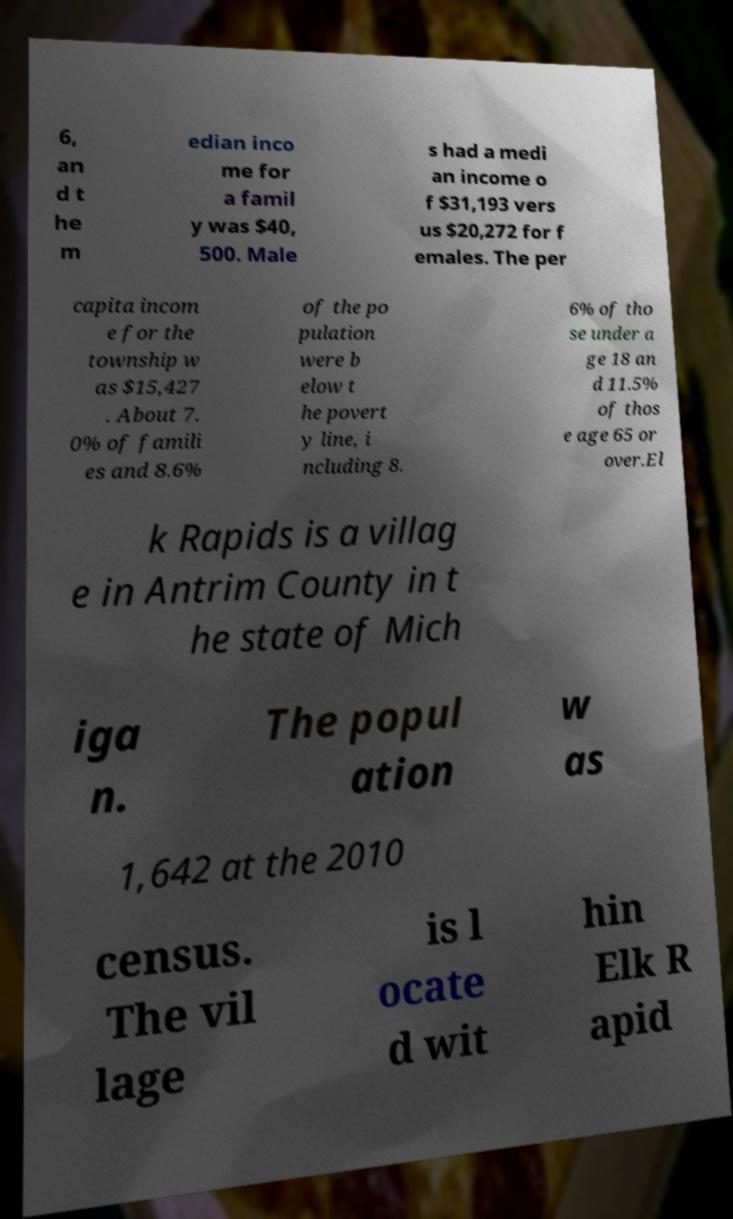Could you extract and type out the text from this image? 6, an d t he m edian inco me for a famil y was $40, 500. Male s had a medi an income o f $31,193 vers us $20,272 for f emales. The per capita incom e for the township w as $15,427 . About 7. 0% of famili es and 8.6% of the po pulation were b elow t he povert y line, i ncluding 8. 6% of tho se under a ge 18 an d 11.5% of thos e age 65 or over.El k Rapids is a villag e in Antrim County in t he state of Mich iga n. The popul ation w as 1,642 at the 2010 census. The vil lage is l ocate d wit hin Elk R apid 